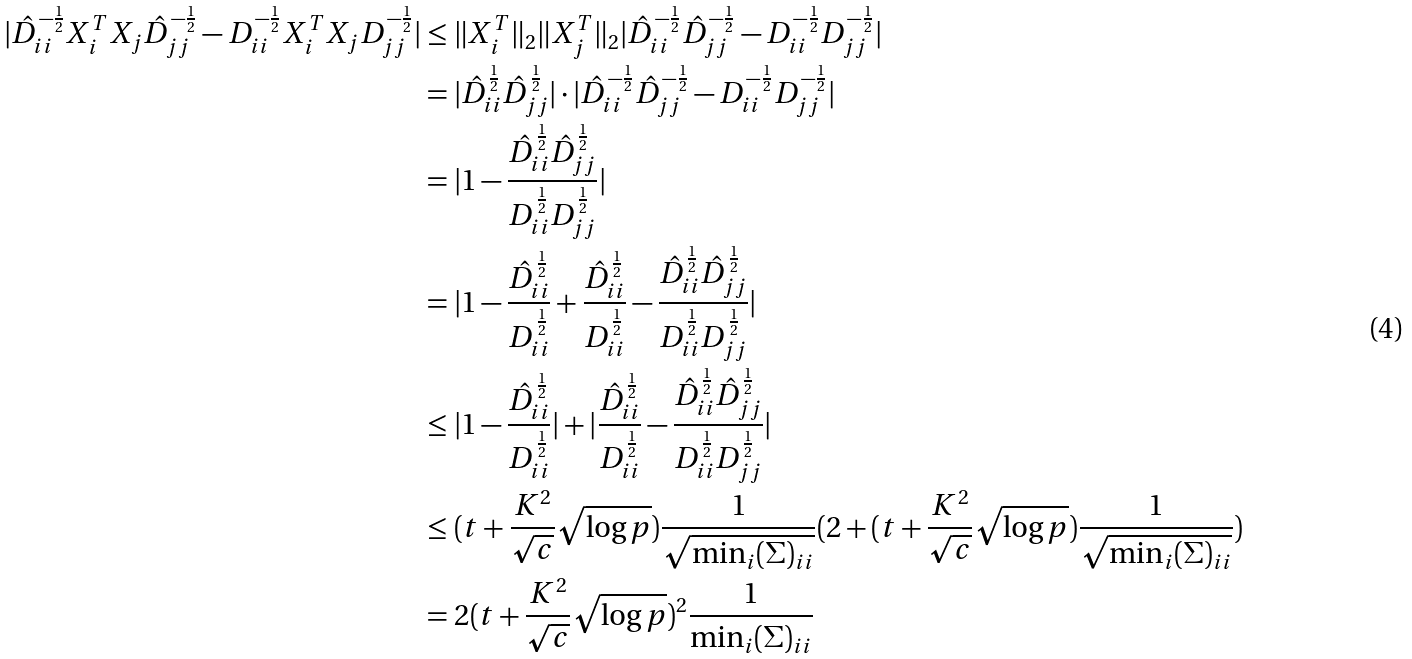Convert formula to latex. <formula><loc_0><loc_0><loc_500><loc_500>| \hat { D } _ { i i } ^ { - \frac { 1 } { 2 } } X _ { i } ^ { T } X _ { j } \hat { D } _ { j j } ^ { - \frac { 1 } { 2 } } - D _ { i i } ^ { - \frac { 1 } { 2 } } X _ { i } ^ { T } X _ { j } D _ { j j } ^ { - \frac { 1 } { 2 } } | & \leq \| X _ { i } ^ { T } \| _ { 2 } \| X _ { j } ^ { T } \| _ { 2 } | \hat { D } _ { i i } ^ { - \frac { 1 } { 2 } } \hat { D } _ { j j } ^ { - \frac { 1 } { 2 } } - D _ { i i } ^ { - \frac { 1 } { 2 } } D _ { j j } ^ { - \frac { 1 } { 2 } } | \\ & = | \hat { D } _ { i i } ^ { \frac { 1 } { 2 } } \hat { D } _ { j j } ^ { \frac { 1 } { 2 } } | \cdot | \hat { D } _ { i i } ^ { - \frac { 1 } { 2 } } \hat { D } _ { j j } ^ { - \frac { 1 } { 2 } } - D _ { i i } ^ { - \frac { 1 } { 2 } } D _ { j j } ^ { - \frac { 1 } { 2 } } | \\ & = | 1 - \frac { \hat { D } _ { i i } ^ { \frac { 1 } { 2 } } \hat { D } _ { j j } ^ { \frac { 1 } { 2 } } } { D _ { i i } ^ { \frac { 1 } { 2 } } D _ { j j } ^ { \frac { 1 } { 2 } } } | \\ & = | 1 - \frac { \hat { D } _ { i i } ^ { \frac { 1 } { 2 } } } { D _ { i i } ^ { \frac { 1 } { 2 } } } + \frac { \hat { D } _ { i i } ^ { \frac { 1 } { 2 } } } { D _ { i i } ^ { \frac { 1 } { 2 } } } - \frac { \hat { D } _ { i i } ^ { \frac { 1 } { 2 } } \hat { D } _ { j j } ^ { \frac { 1 } { 2 } } } { D _ { i i } ^ { \frac { 1 } { 2 } } D _ { j j } ^ { \frac { 1 } { 2 } } } | \\ & \leq | 1 - \frac { \hat { D } _ { i i } ^ { \frac { 1 } { 2 } } } { D _ { i i } ^ { \frac { 1 } { 2 } } } | + | \frac { \hat { D } _ { i i } ^ { \frac { 1 } { 2 } } } { D _ { i i } ^ { \frac { 1 } { 2 } } } - \frac { \hat { D } _ { i i } ^ { \frac { 1 } { 2 } } \hat { D } _ { j j } ^ { \frac { 1 } { 2 } } } { D _ { i i } ^ { \frac { 1 } { 2 } } D _ { j j } ^ { \frac { 1 } { 2 } } } | \\ & \leq ( t + \frac { K ^ { 2 } } { \sqrt { c } } \sqrt { \log p } ) \frac { 1 } { \sqrt { \min _ { i } ( \Sigma ) _ { i i } } } ( 2 + ( t + \frac { K ^ { 2 } } { \sqrt { c } } \sqrt { \log p } ) \frac { 1 } { \sqrt { \min _ { i } ( \Sigma ) _ { i i } } } ) \\ & = 2 ( t + \frac { K ^ { 2 } } { \sqrt { c } } \sqrt { \log p } ) ^ { 2 } \frac { 1 } { \min _ { i } ( \Sigma ) _ { i i } }</formula> 